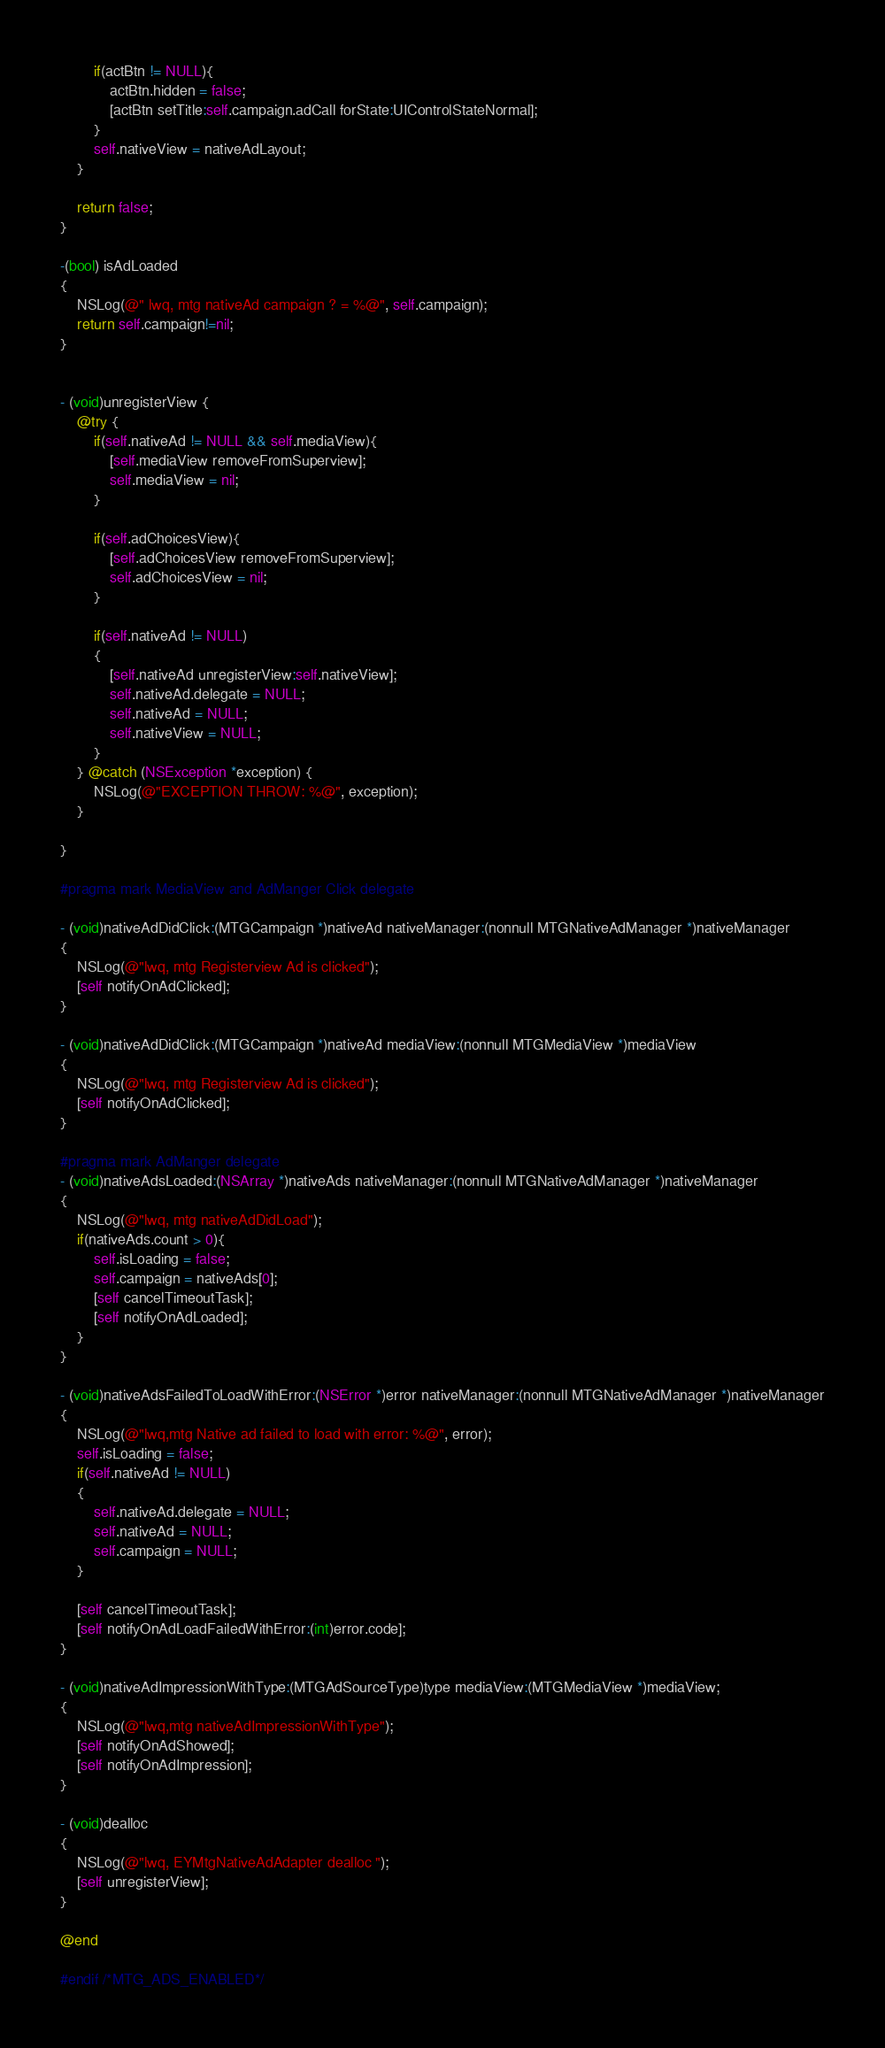<code> <loc_0><loc_0><loc_500><loc_500><_ObjectiveC_>        if(actBtn != NULL){
            actBtn.hidden = false;
            [actBtn setTitle:self.campaign.adCall forState:UIControlStateNormal];
        }
        self.nativeView = nativeAdLayout;
    }
    
    return false;
}

-(bool) isAdLoaded
{
    NSLog(@" lwq, mtg nativeAd campaign ? = %@", self.campaign);
    return self.campaign!=nil;
}


- (void)unregisterView {
    @try {
        if(self.nativeAd != NULL && self.mediaView){
            [self.mediaView removeFromSuperview];
            self.mediaView = nil;
        }
        
        if(self.adChoicesView){
            [self.adChoicesView removeFromSuperview];
            self.adChoicesView = nil;
        }
        
        if(self.nativeAd != NULL)
        {
            [self.nativeAd unregisterView:self.nativeView];
            self.nativeAd.delegate = NULL;
            self.nativeAd = NULL;
            self.nativeView = NULL;
        }
    } @catch (NSException *exception) {
        NSLog(@"EXCEPTION THROW: %@", exception);
    }
    
}

#pragma mark MediaView and AdManger Click delegate

- (void)nativeAdDidClick:(MTGCampaign *)nativeAd nativeManager:(nonnull MTGNativeAdManager *)nativeManager
{
    NSLog(@"lwq, mtg Registerview Ad is clicked");
    [self notifyOnAdClicked];
}

- (void)nativeAdDidClick:(MTGCampaign *)nativeAd mediaView:(nonnull MTGMediaView *)mediaView
{
    NSLog(@"lwq, mtg Registerview Ad is clicked");
    [self notifyOnAdClicked];
}

#pragma mark AdManger delegate
- (void)nativeAdsLoaded:(NSArray *)nativeAds nativeManager:(nonnull MTGNativeAdManager *)nativeManager
{
    NSLog(@"lwq, mtg nativeAdDidLoad");
    if(nativeAds.count > 0){
        self.isLoading = false;
        self.campaign = nativeAds[0];
        [self cancelTimeoutTask];
        [self notifyOnAdLoaded];
    }
}

- (void)nativeAdsFailedToLoadWithError:(NSError *)error nativeManager:(nonnull MTGNativeAdManager *)nativeManager
{
    NSLog(@"lwq,mtg Native ad failed to load with error: %@", error);
    self.isLoading = false;
    if(self.nativeAd != NULL)
    {
        self.nativeAd.delegate = NULL;
        self.nativeAd = NULL;
        self.campaign = NULL;
    }
    
    [self cancelTimeoutTask];
    [self notifyOnAdLoadFailedWithError:(int)error.code];
}

- (void)nativeAdImpressionWithType:(MTGAdSourceType)type mediaView:(MTGMediaView *)mediaView;
{
    NSLog(@"lwq,mtg nativeAdImpressionWithType");
    [self notifyOnAdShowed];
    [self notifyOnAdImpression];
}

- (void)dealloc
{
    NSLog(@"lwq, EYMtgNativeAdAdapter dealloc ");
    [self unregisterView];
}

@end

#endif /*MTG_ADS_ENABLED*/
</code> 